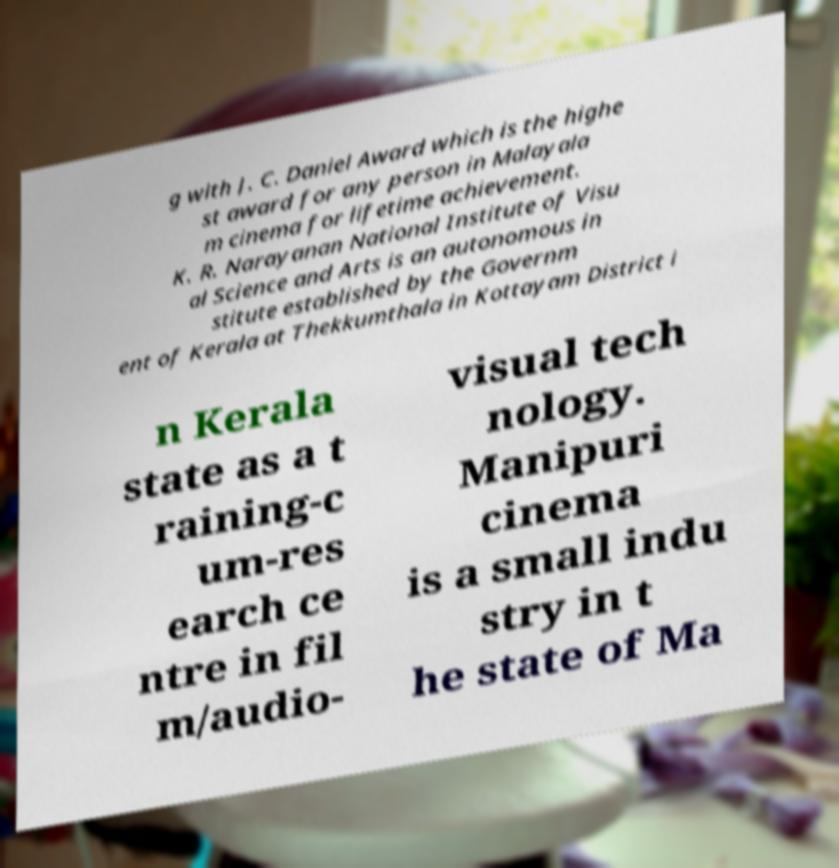Can you accurately transcribe the text from the provided image for me? g with J. C. Daniel Award which is the highe st award for any person in Malayala m cinema for lifetime achievement. K. R. Narayanan National Institute of Visu al Science and Arts is an autonomous in stitute established by the Governm ent of Kerala at Thekkumthala in Kottayam District i n Kerala state as a t raining-c um-res earch ce ntre in fil m/audio- visual tech nology. Manipuri cinema is a small indu stry in t he state of Ma 